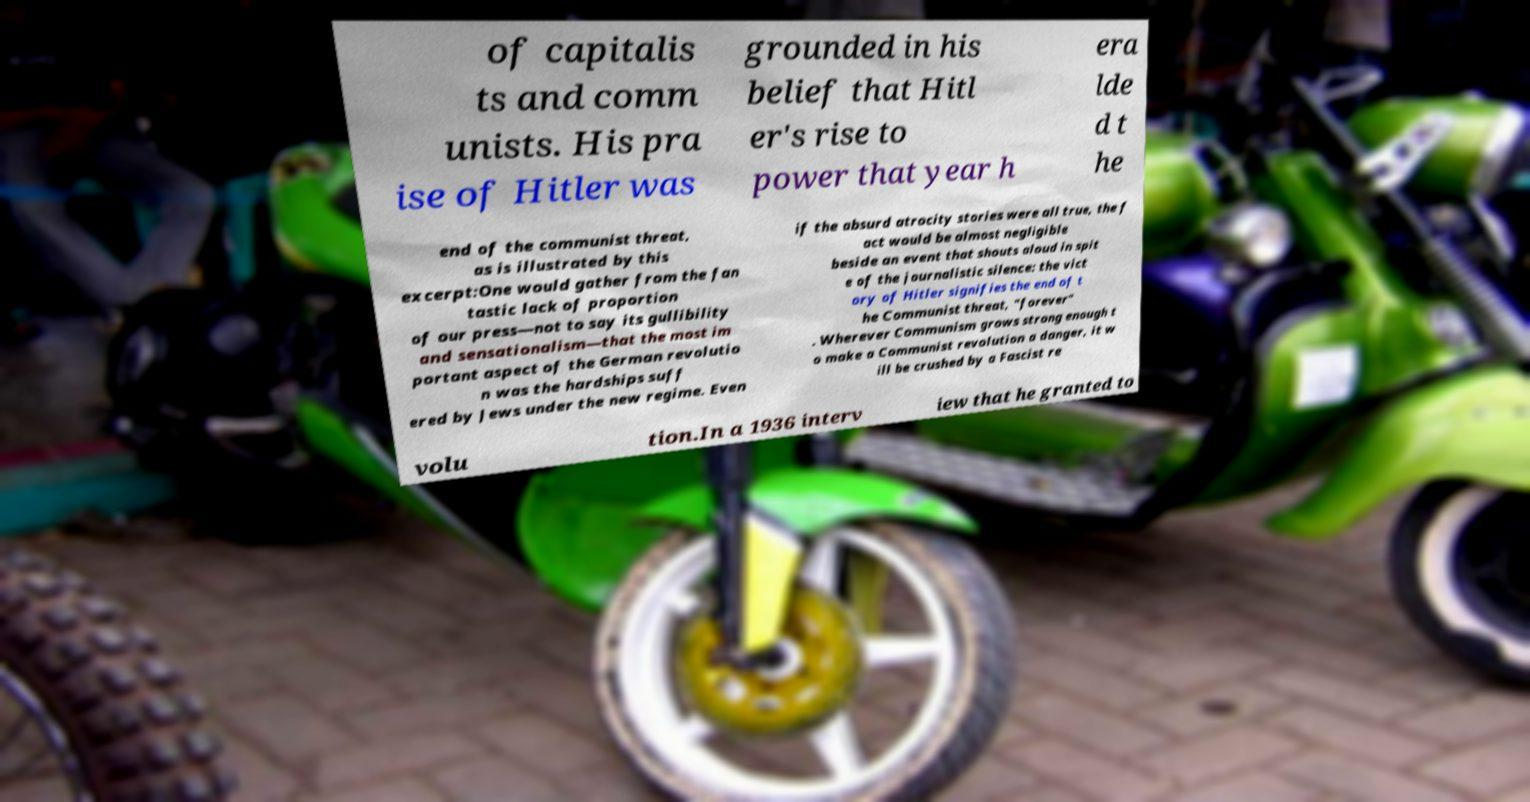Could you assist in decoding the text presented in this image and type it out clearly? of capitalis ts and comm unists. His pra ise of Hitler was grounded in his belief that Hitl er's rise to power that year h era lde d t he end of the communist threat, as is illustrated by this excerpt:One would gather from the fan tastic lack of proportion of our press—not to say its gullibility and sensationalism—that the most im portant aspect of the German revolutio n was the hardships suff ered by Jews under the new regime. Even if the absurd atrocity stories were all true, the f act would be almost negligible beside an event that shouts aloud in spit e of the journalistic silence: the vict ory of Hitler signifies the end of t he Communist threat, "forever" . Wherever Communism grows strong enough t o make a Communist revolution a danger, it w ill be crushed by a Fascist re volu tion.In a 1936 interv iew that he granted to 